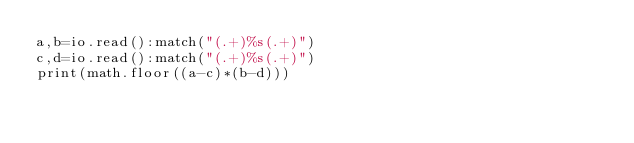Convert code to text. <code><loc_0><loc_0><loc_500><loc_500><_Lua_>a,b=io.read():match("(.+)%s(.+)")
c,d=io.read():match("(.+)%s(.+)")
print(math.floor((a-c)*(b-d)))</code> 